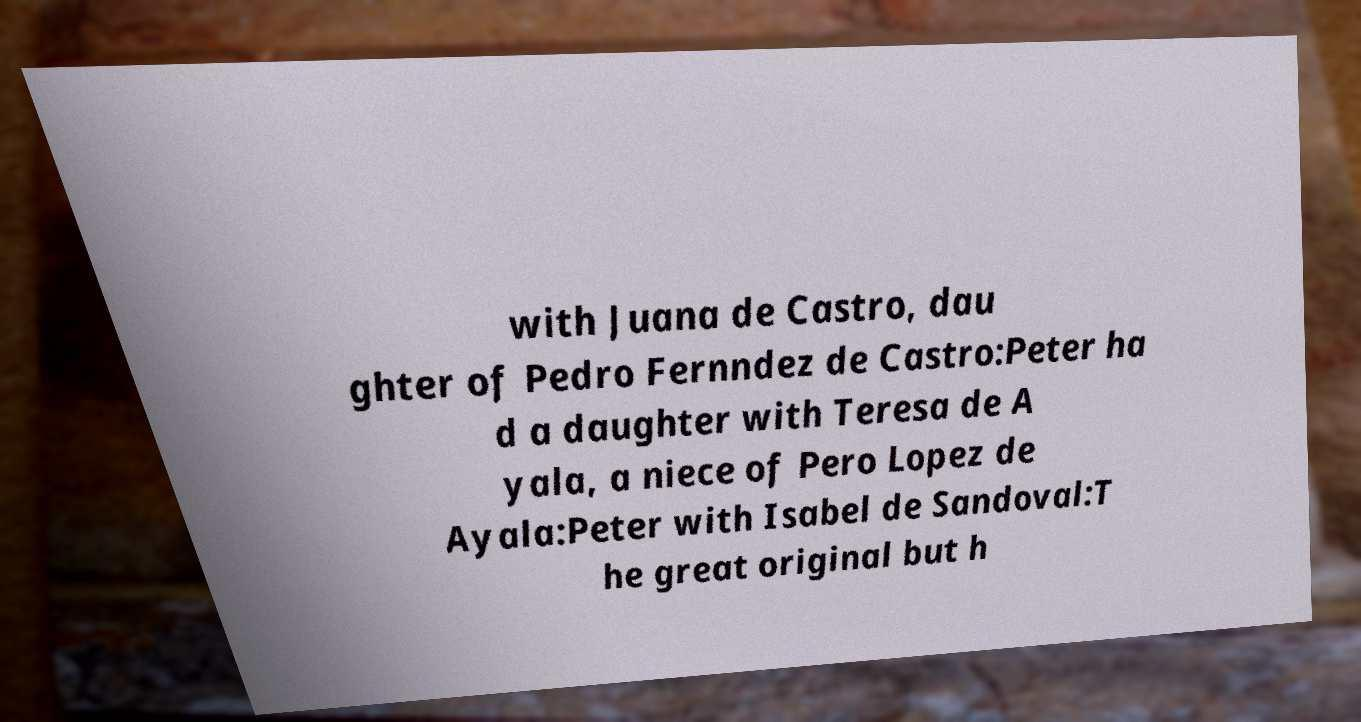Could you assist in decoding the text presented in this image and type it out clearly? with Juana de Castro, dau ghter of Pedro Fernndez de Castro:Peter ha d a daughter with Teresa de A yala, a niece of Pero Lopez de Ayala:Peter with Isabel de Sandoval:T he great original but h 